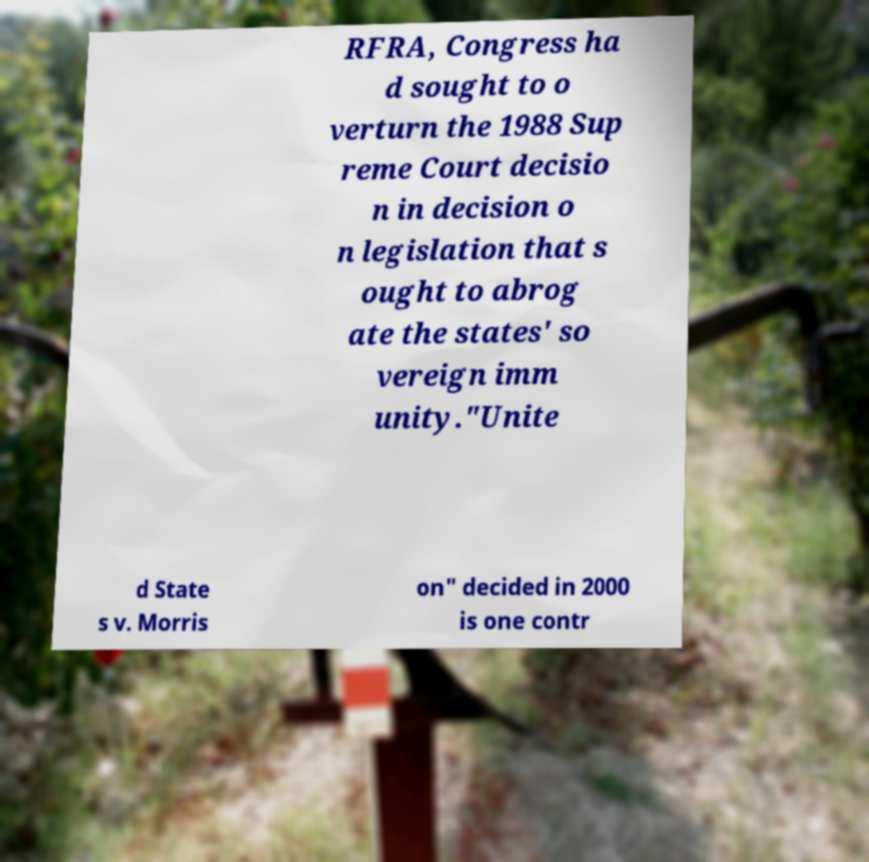What messages or text are displayed in this image? I need them in a readable, typed format. RFRA, Congress ha d sought to o verturn the 1988 Sup reme Court decisio n in decision o n legislation that s ought to abrog ate the states' so vereign imm unity."Unite d State s v. Morris on" decided in 2000 is one contr 